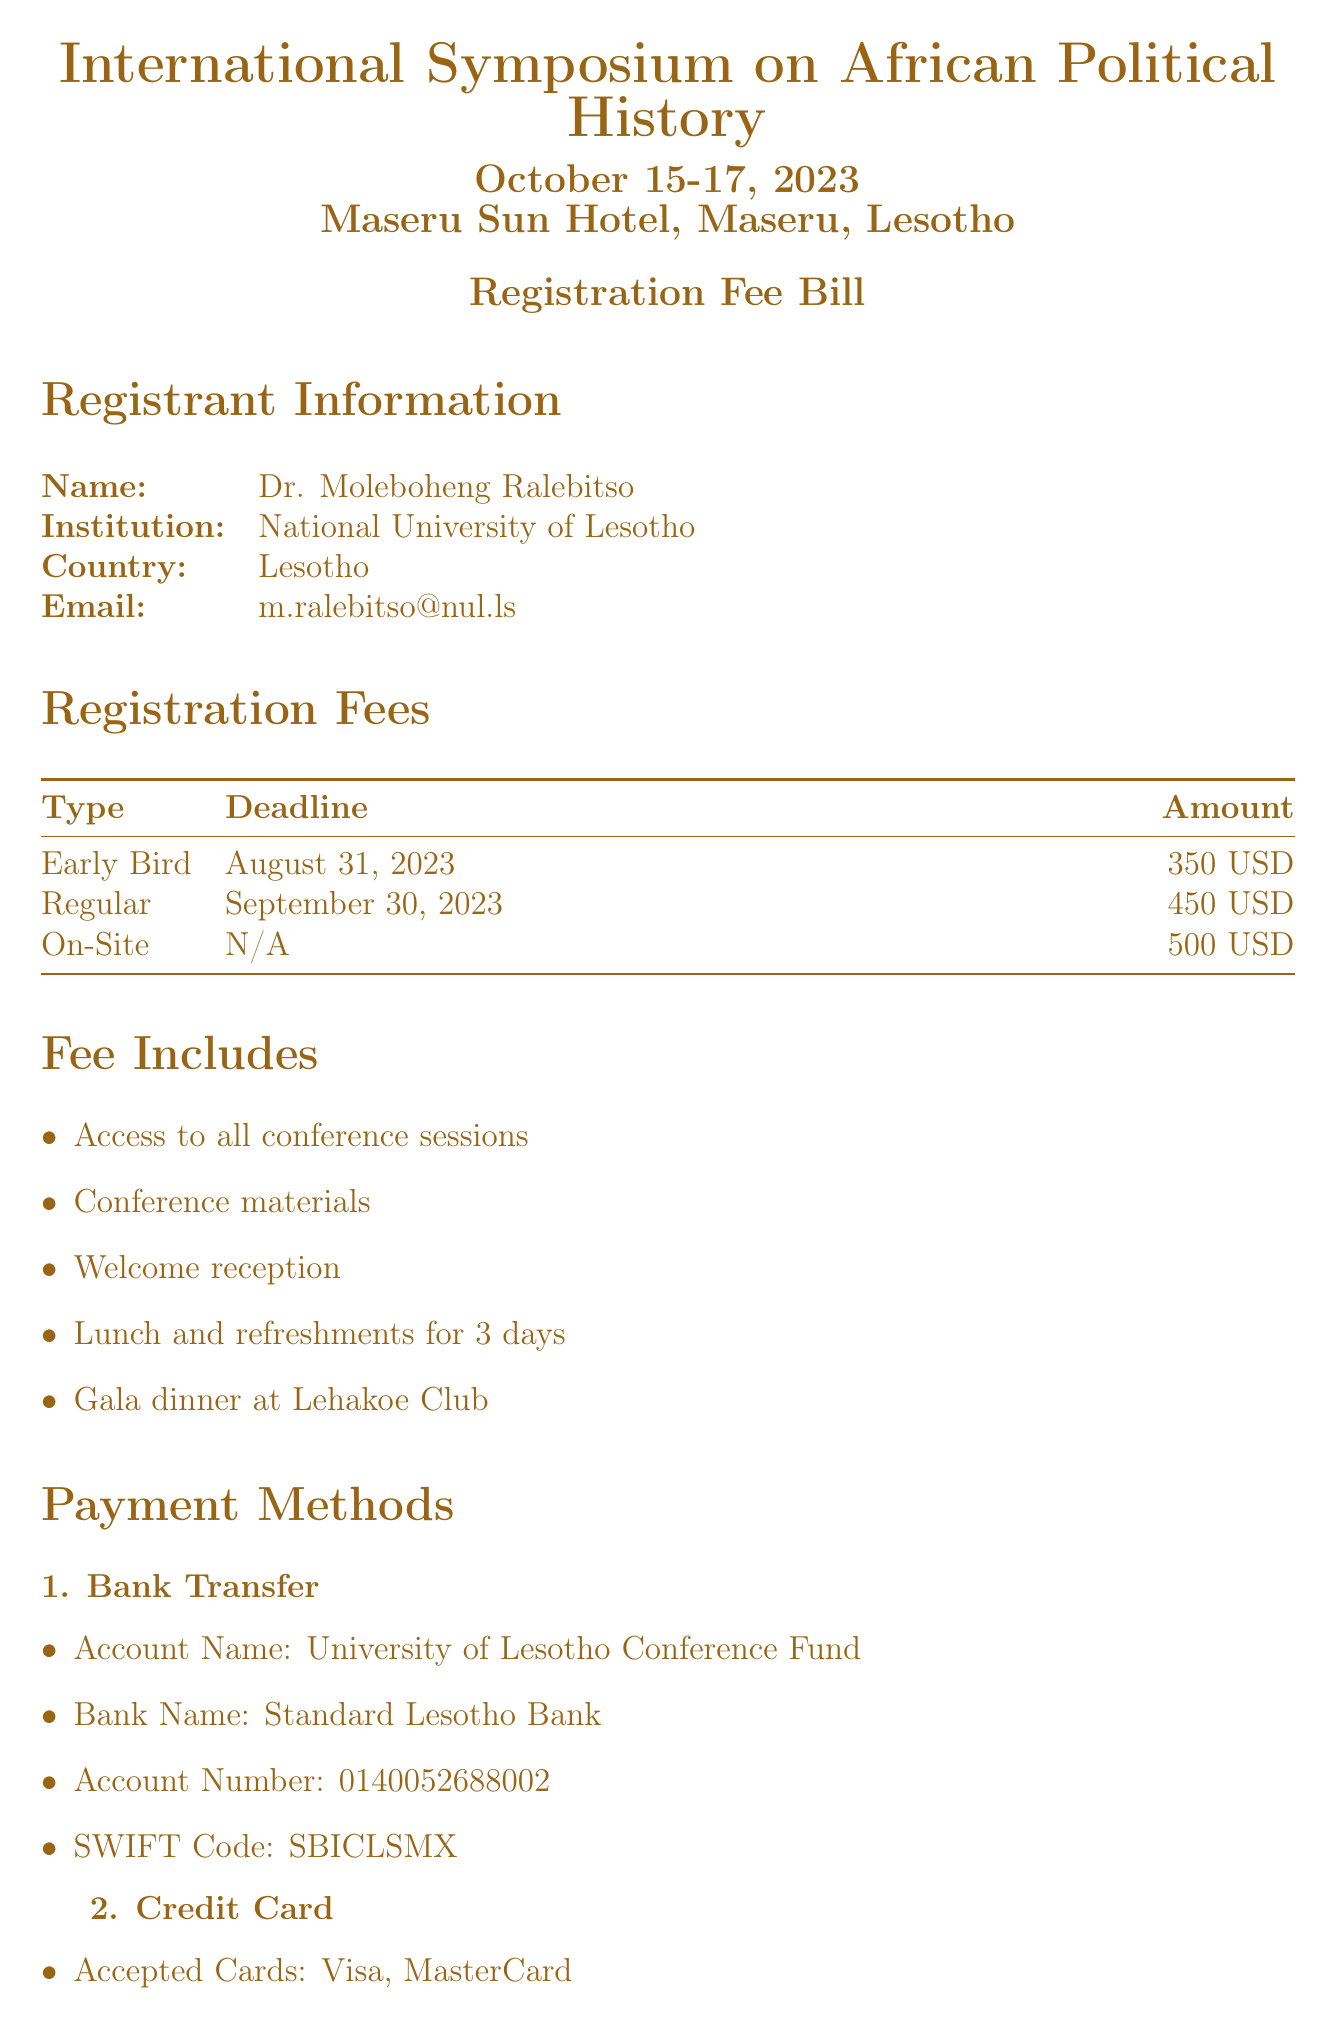What is the registration fee for early bird registrants? The early bird registration fee is specified under Registration Fees, which totals 350 USD.
Answer: 350 USD What is the cancellation policy after October 1? Based on the Cancellation Policy section, there is no refund after this date.
Answer: No refund What is the location of the symposium? The location is indicated at the top of the document, specifically the Maseru Sun Hotel, Maseru, Lesotho.
Answer: Maseru Sun Hotel, Maseru, Lesotho How many days does the fee include lunch and refreshments? The document states that lunch and refreshments are included for 3 days, as listed under Fee Includes.
Answer: 3 days What account name should payments be made to? The account name is given under Payment Methods, indicating payments should be made to the University of Lesotho Conference Fund.
Answer: University of Lesotho Conference Fund What is the amount for regular registration? The amount for regular registration is clearly mentioned under Registration Fees, which is 450 USD.
Answer: 450 USD Which credit cards are accepted for payment? Under Payment Methods, it is specified that Visa and MasterCard are accepted cards.
Answer: Visa, MasterCard What is the processing fee for cancellations before September 15? It is stated in the Cancellation Policy that the processing fee is 50 USD.
Answer: 50 USD What dates does the symposium occur? The dates for the symposium are clearly mentioned in the heading as October 15-17, 2023.
Answer: October 15-17, 2023 